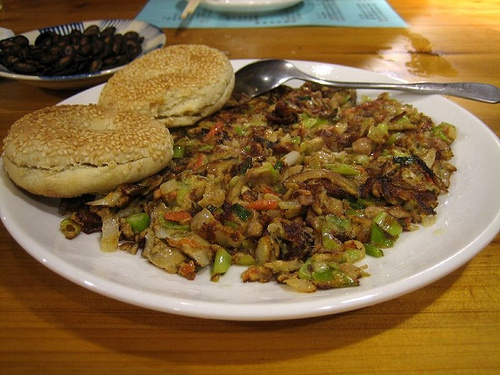Describe the objects in this image and their specific colors. I can see dining table in maroon, olive, and orange tones, bowl in maroon, black, and gray tones, spoon in maroon, gray, black, darkgray, and darkgreen tones, broccoli in maroon, olive, and tan tones, and broccoli in maroon, olive, and black tones in this image. 